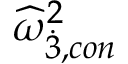Convert formula to latex. <formula><loc_0><loc_0><loc_500><loc_500>{ \widehat { \omega } } _ { \dot { 3 } , c o n } ^ { 2 }</formula> 